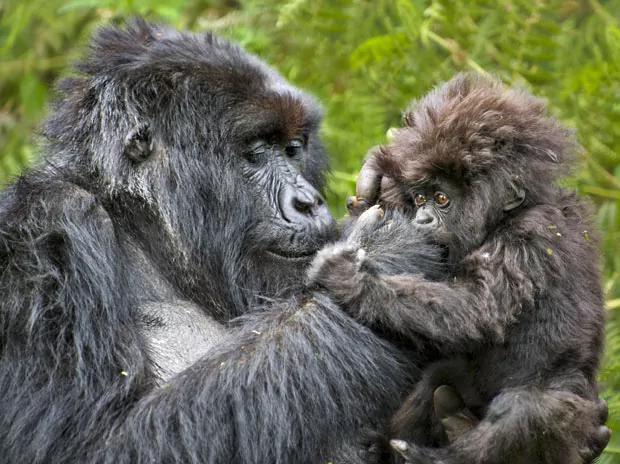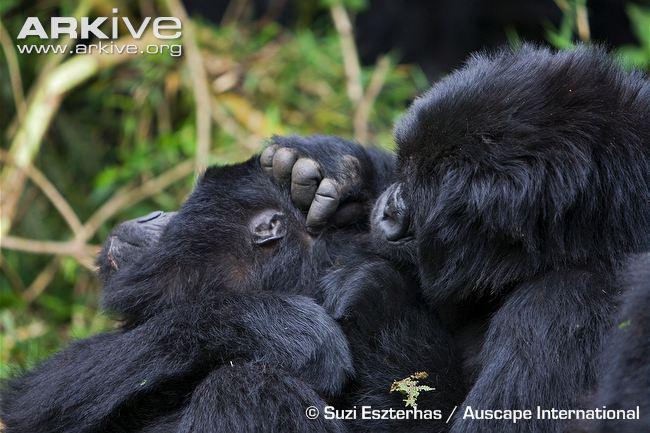The first image is the image on the left, the second image is the image on the right. For the images displayed, is the sentence "One image shows one shaggy-haired gorilla grooming the head of a different shaggy haired gorilla, with the curled fingers of one hand facing the camera." factually correct? Answer yes or no. Yes. The first image is the image on the left, the second image is the image on the right. Examine the images to the left and right. Is the description "One of the images depicts a gorilla grooming from behind it." accurate? Answer yes or no. Yes. 